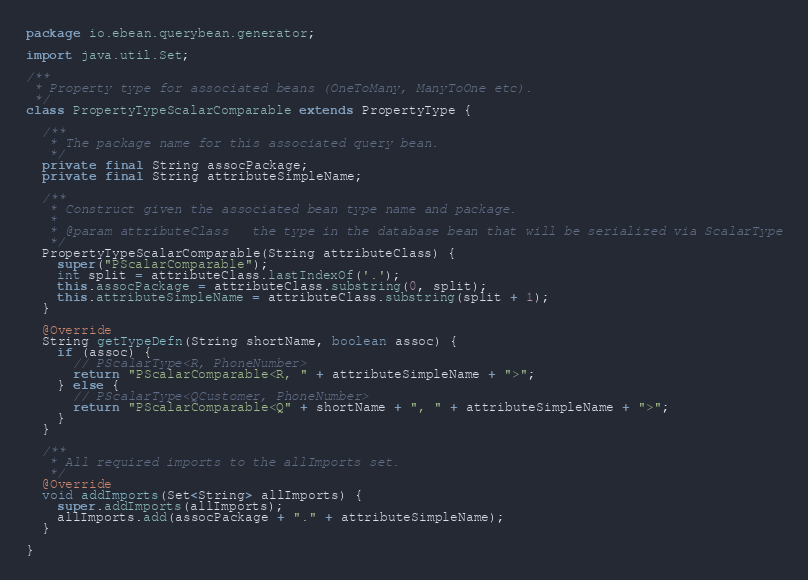<code> <loc_0><loc_0><loc_500><loc_500><_Java_>package io.ebean.querybean.generator;

import java.util.Set;

/**
 * Property type for associated beans (OneToMany, ManyToOne etc).
 */
class PropertyTypeScalarComparable extends PropertyType {

  /**
   * The package name for this associated query bean.
   */
  private final String assocPackage;
  private final String attributeSimpleName;

  /**
   * Construct given the associated bean type name and package.
   *
   * @param attributeClass   the type in the database bean that will be serialized via ScalarType
   */
  PropertyTypeScalarComparable(String attributeClass) {
    super("PScalarComparable");
    int split = attributeClass.lastIndexOf('.');
    this.assocPackage = attributeClass.substring(0, split);
    this.attributeSimpleName = attributeClass.substring(split + 1);
  }

  @Override
  String getTypeDefn(String shortName, boolean assoc) {
    if (assoc) {
      // PScalarType<R, PhoneNumber>
      return "PScalarComparable<R, " + attributeSimpleName + ">";
    } else {
      // PScalarType<QCustomer, PhoneNumber>
      return "PScalarComparable<Q" + shortName + ", " + attributeSimpleName + ">";
    }
  }

  /**
   * All required imports to the allImports set.
   */
  @Override
  void addImports(Set<String> allImports) {
    super.addImports(allImports);
    allImports.add(assocPackage + "." + attributeSimpleName);
  }

}
</code> 